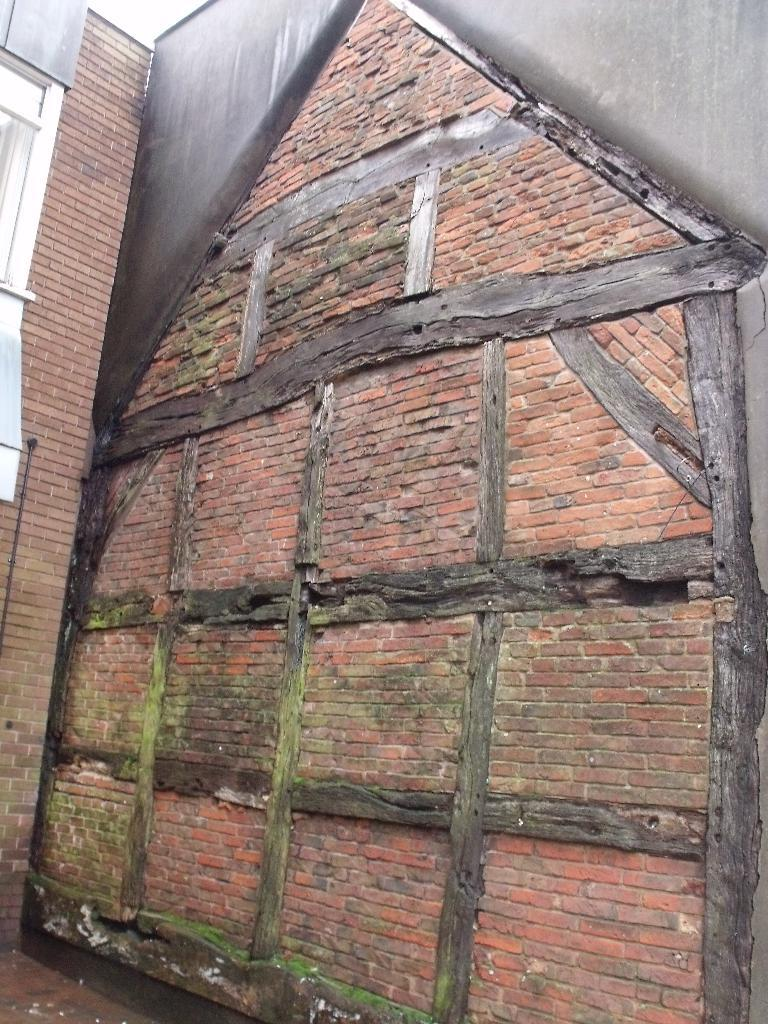What type of wall is shown in the image? There is an old timber and brick wall in the image. What can be seen under the wall in the image? The floor is visible in the image. Is there any opening in the wall visible in the image? Yes, there is a window in the image. What type of agreement was reached during the lunch depicted in the image? There is no lunch or agreement depicted in the image; it only shows an old timber and brick wall, the floor, and a window. 